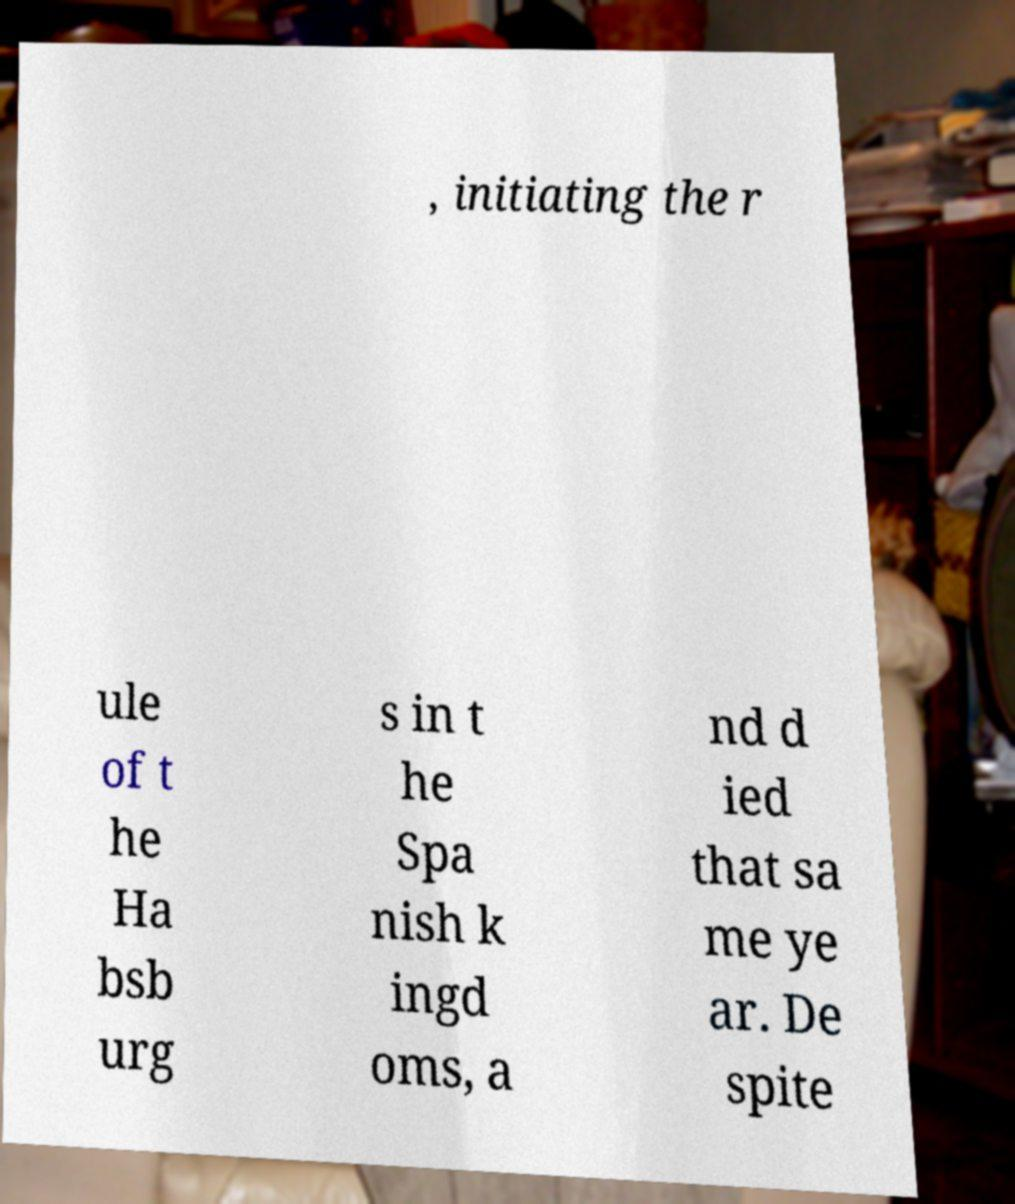Can you read and provide the text displayed in the image?This photo seems to have some interesting text. Can you extract and type it out for me? , initiating the r ule of t he Ha bsb urg s in t he Spa nish k ingd oms, a nd d ied that sa me ye ar. De spite 